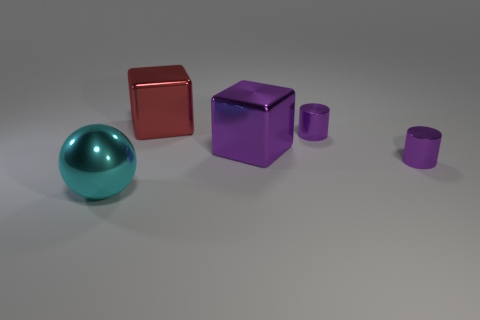Is the material of the large purple thing the same as the red block?
Your answer should be compact. Yes. How many big cyan metallic spheres are behind the tiny purple shiny object left of the tiny purple cylinder in front of the big purple cube?
Offer a terse response. 0. There is a object to the left of the big red shiny thing; what is its shape?
Keep it short and to the point. Sphere. How many other things are made of the same material as the big cyan object?
Provide a succinct answer. 4. Is the number of large things to the left of the purple block less than the number of shiny things right of the large cyan sphere?
Your response must be concise. Yes. There is another shiny thing that is the same shape as the big red object; what is its color?
Your answer should be compact. Purple. There is a purple metal object in front of the purple cube; does it have the same size as the cyan shiny thing?
Provide a succinct answer. No. Are there fewer large metal things that are in front of the shiny sphere than large blocks?
Ensure brevity in your answer.  Yes. Are there any other things that are the same size as the red metallic cube?
Ensure brevity in your answer.  Yes. There is a shiny object in front of the small purple object that is in front of the purple metallic block; how big is it?
Provide a succinct answer. Large. 